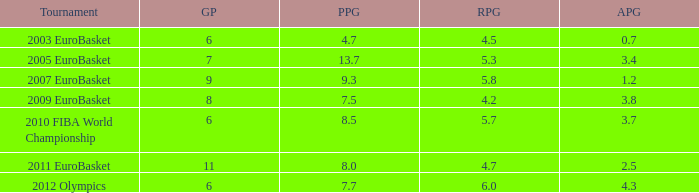How many games played have 4.7 points per game? 1.0. 